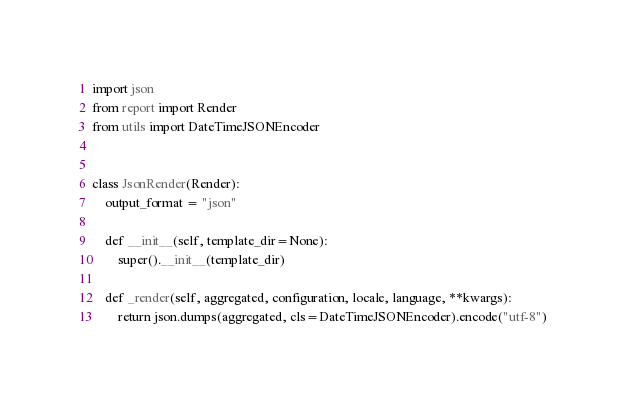Convert code to text. <code><loc_0><loc_0><loc_500><loc_500><_Python_>import json
from report import Render
from utils import DateTimeJSONEncoder


class JsonRender(Render):
    output_format = "json"

    def __init__(self, template_dir=None):
        super().__init__(template_dir)

    def _render(self, aggregated, configuration, locale, language, **kwargs):
        return json.dumps(aggregated, cls=DateTimeJSONEncoder).encode("utf-8")
</code> 